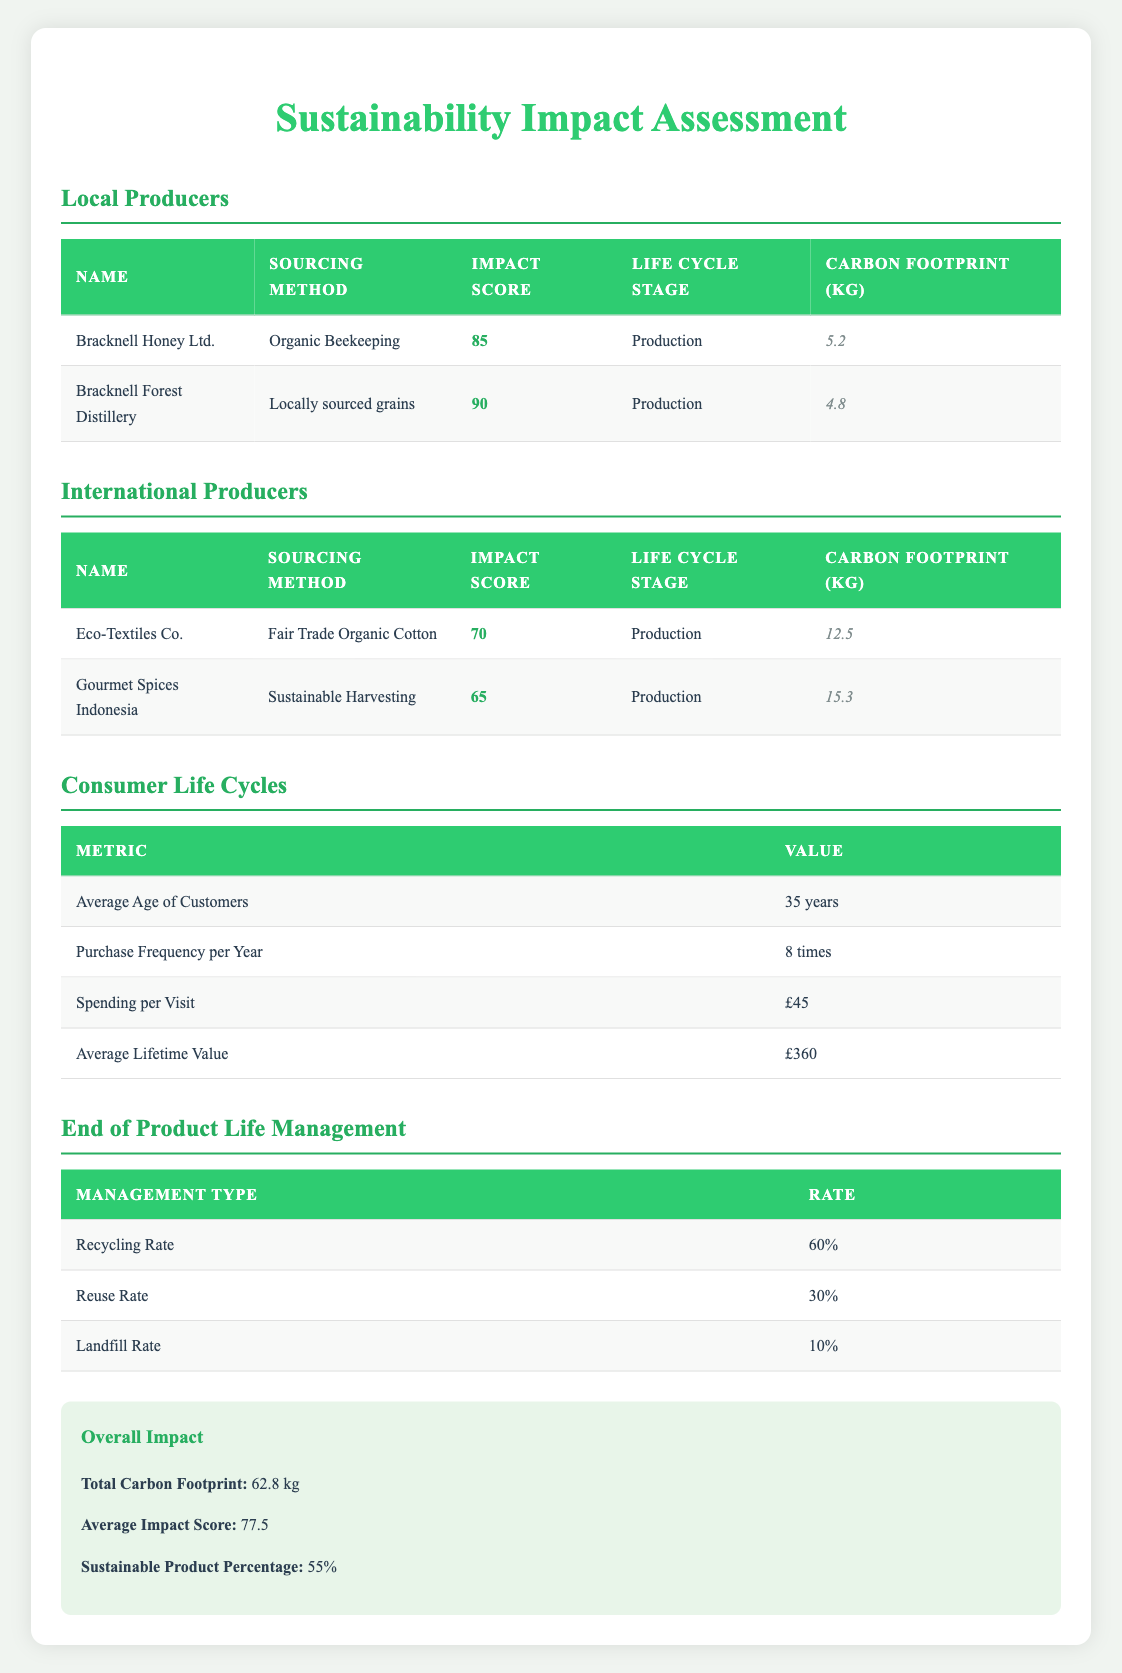What is the impact score of Bracknell Forest Distillery? The impact score for Bracknell Forest Distillery is directly provided in the table under the Local Producers section. It shows an impact score of 90.
Answer: 90 What is the total carbon footprint from all the products sourced? The table indicates the total carbon footprint is summarized under Overall Impact, which states a total of 62.8 kg.
Answer: 62.8 kg Which local producer has the highest impact score? By comparing the impact scores of both local producers, Bracknell Forest Distillery has an impact score of 90, while Bracknell Honey Ltd. has an impact score of 85. Therefore, Bracknell Forest Distillery has the highest impact score.
Answer: Bracknell Forest Distillery Is the average age of customers in Bracknell Forest above 30? The table lists the average age of customers as 35 years, which is indeed above 30.
Answer: Yes What is the average impact score for local producers? To calculate the average impact score for local producers, add the scores of both producers: 85 (Bracknell Honey Ltd.) + 90 (Bracknell Forest Distillery) = 175. Then, divide by the number of producers (2): 175 / 2 = 87.5.
Answer: 87.5 What percentage of products are sourced sustainably? The overall impact section states that 55% of products are classified as sustainable based on the assessment.
Answer: 55% How much higher is the carbon footprint of Eco-Textiles Co. compared to Bracknell Honey Ltd.? Eco-Textiles Co. has a carbon footprint of 12.5 kg while Bracknell Honey Ltd. has 5.2 kg. The difference is 12.5 - 5.2 = 7.3 kg. Therefore, Eco-Textiles Co. has a carbon footprint that is 7.3 kg higher than Bracknell Honey Ltd.
Answer: 7.3 kg What sourcing method does Gourmet Spices Indonesia use? The sourcing method for Gourmet Spices Indonesia is listed in the table as "Sustainable Harvesting."
Answer: Sustainable Harvesting Is the recycling rate higher than the reuse rate in end-of-product-life management? The table lists the recycling rate as 60% and the reuse rate as 30%. Since 60% is higher than 30%, the statement is true.
Answer: Yes 